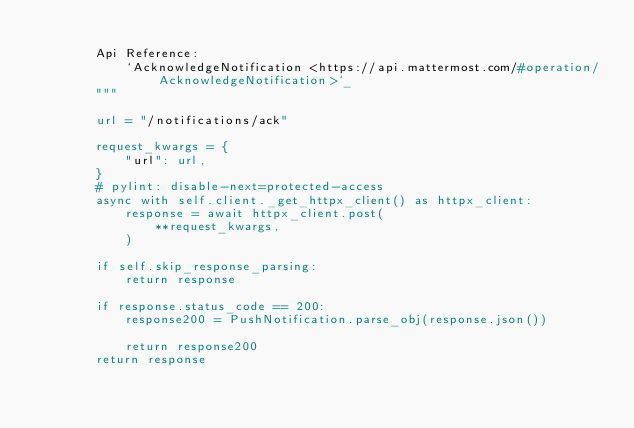<code> <loc_0><loc_0><loc_500><loc_500><_Python_>
        Api Reference:
            `AcknowledgeNotification <https://api.mattermost.com/#operation/AcknowledgeNotification>`_
        """

        url = "/notifications/ack"

        request_kwargs = {
            "url": url,
        }
        # pylint: disable-next=protected-access
        async with self.client._get_httpx_client() as httpx_client:
            response = await httpx_client.post(
                **request_kwargs,
            )

        if self.skip_response_parsing:
            return response

        if response.status_code == 200:
            response200 = PushNotification.parse_obj(response.json())

            return response200
        return response
</code> 